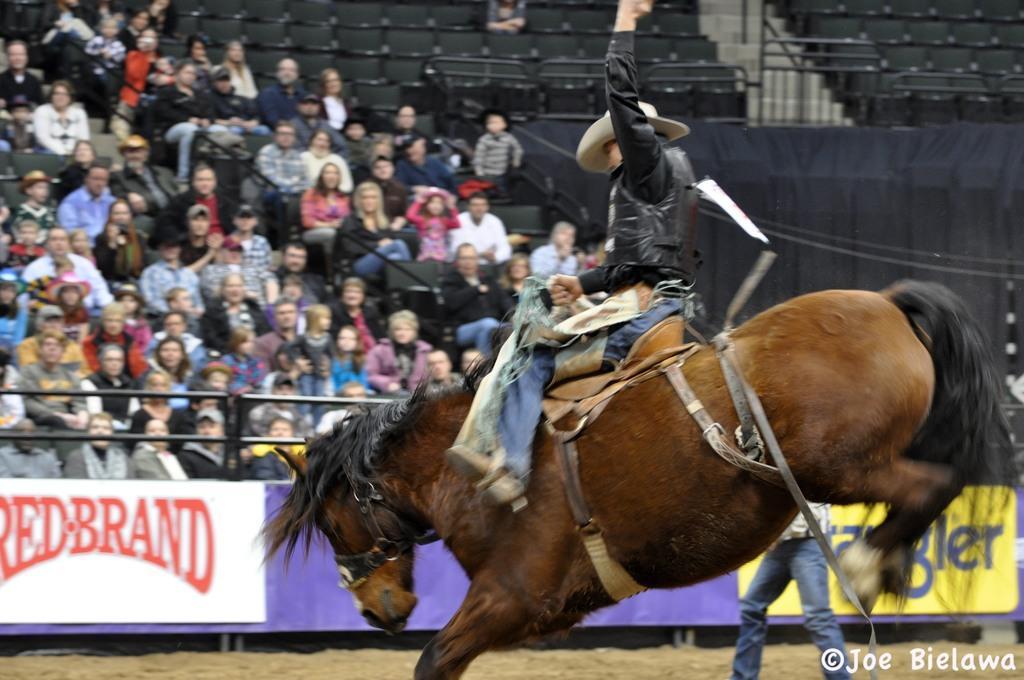Can you describe this image briefly? A man is trying to control a horse by sitting on it. He wears a hat. There are some audience watching. 